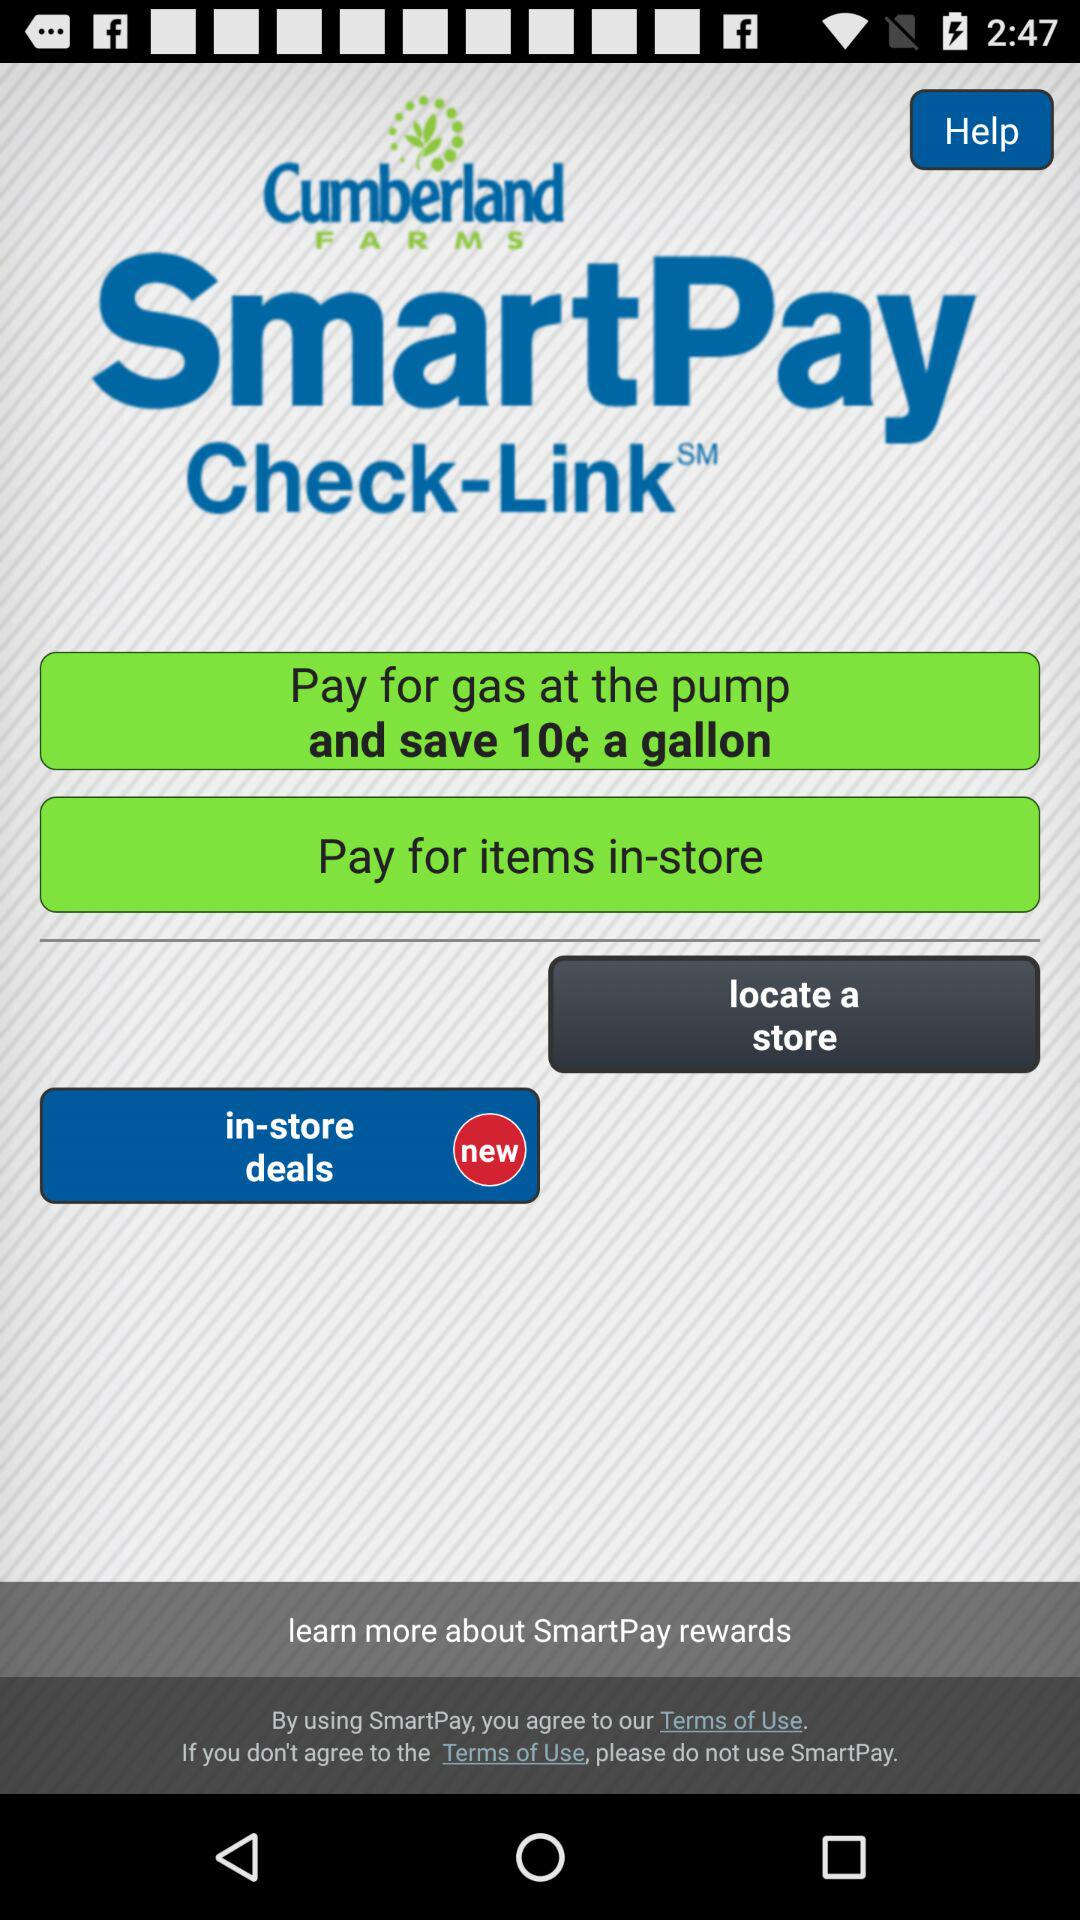How much can be saved by paying for gas at the pump? The amount that can be saved by paying for gas at the pump is 10 cents a gallon. 